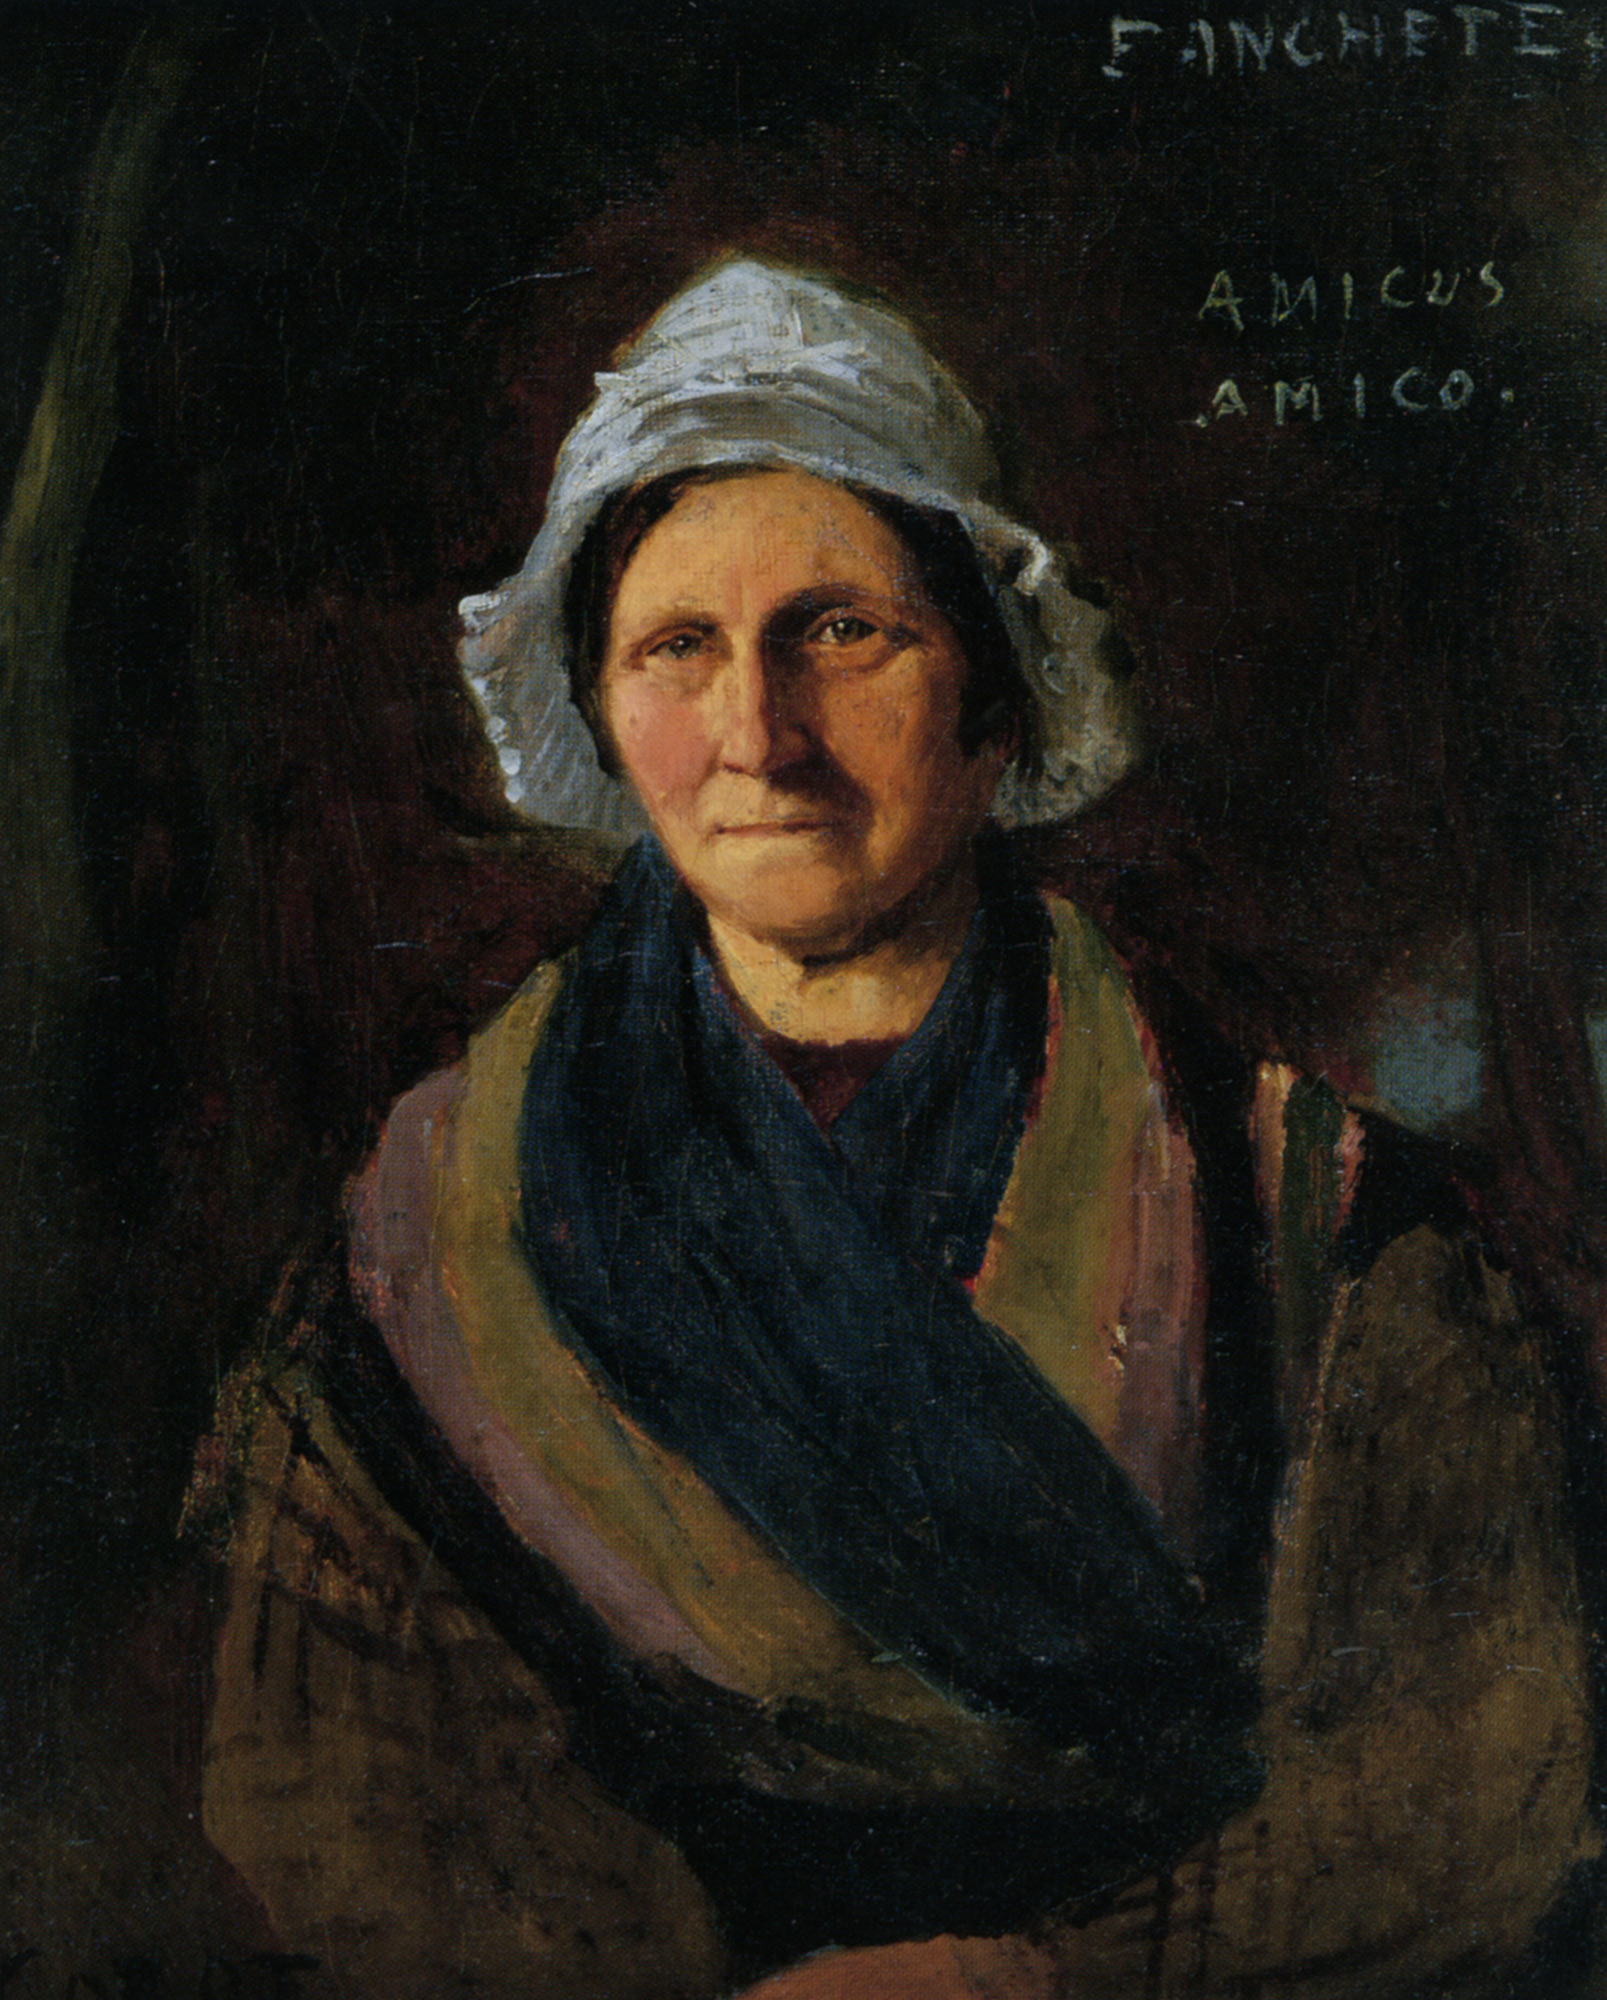Can you analyze the significance of the color choices in the woman's clothing? The use of color in the woman's clothing is quite symbolic. The stark white of the bonnet traditionally represents purity and humility, which may reflect the woman's character. The deep blue shawl provides a rich contrast, often associated with depth and stability, suggesting that the woman may possess strong emotional or moral fortitude. These color choices are not only aesthetically striking but also contribute to a deeper understanding of the subject's personality. 